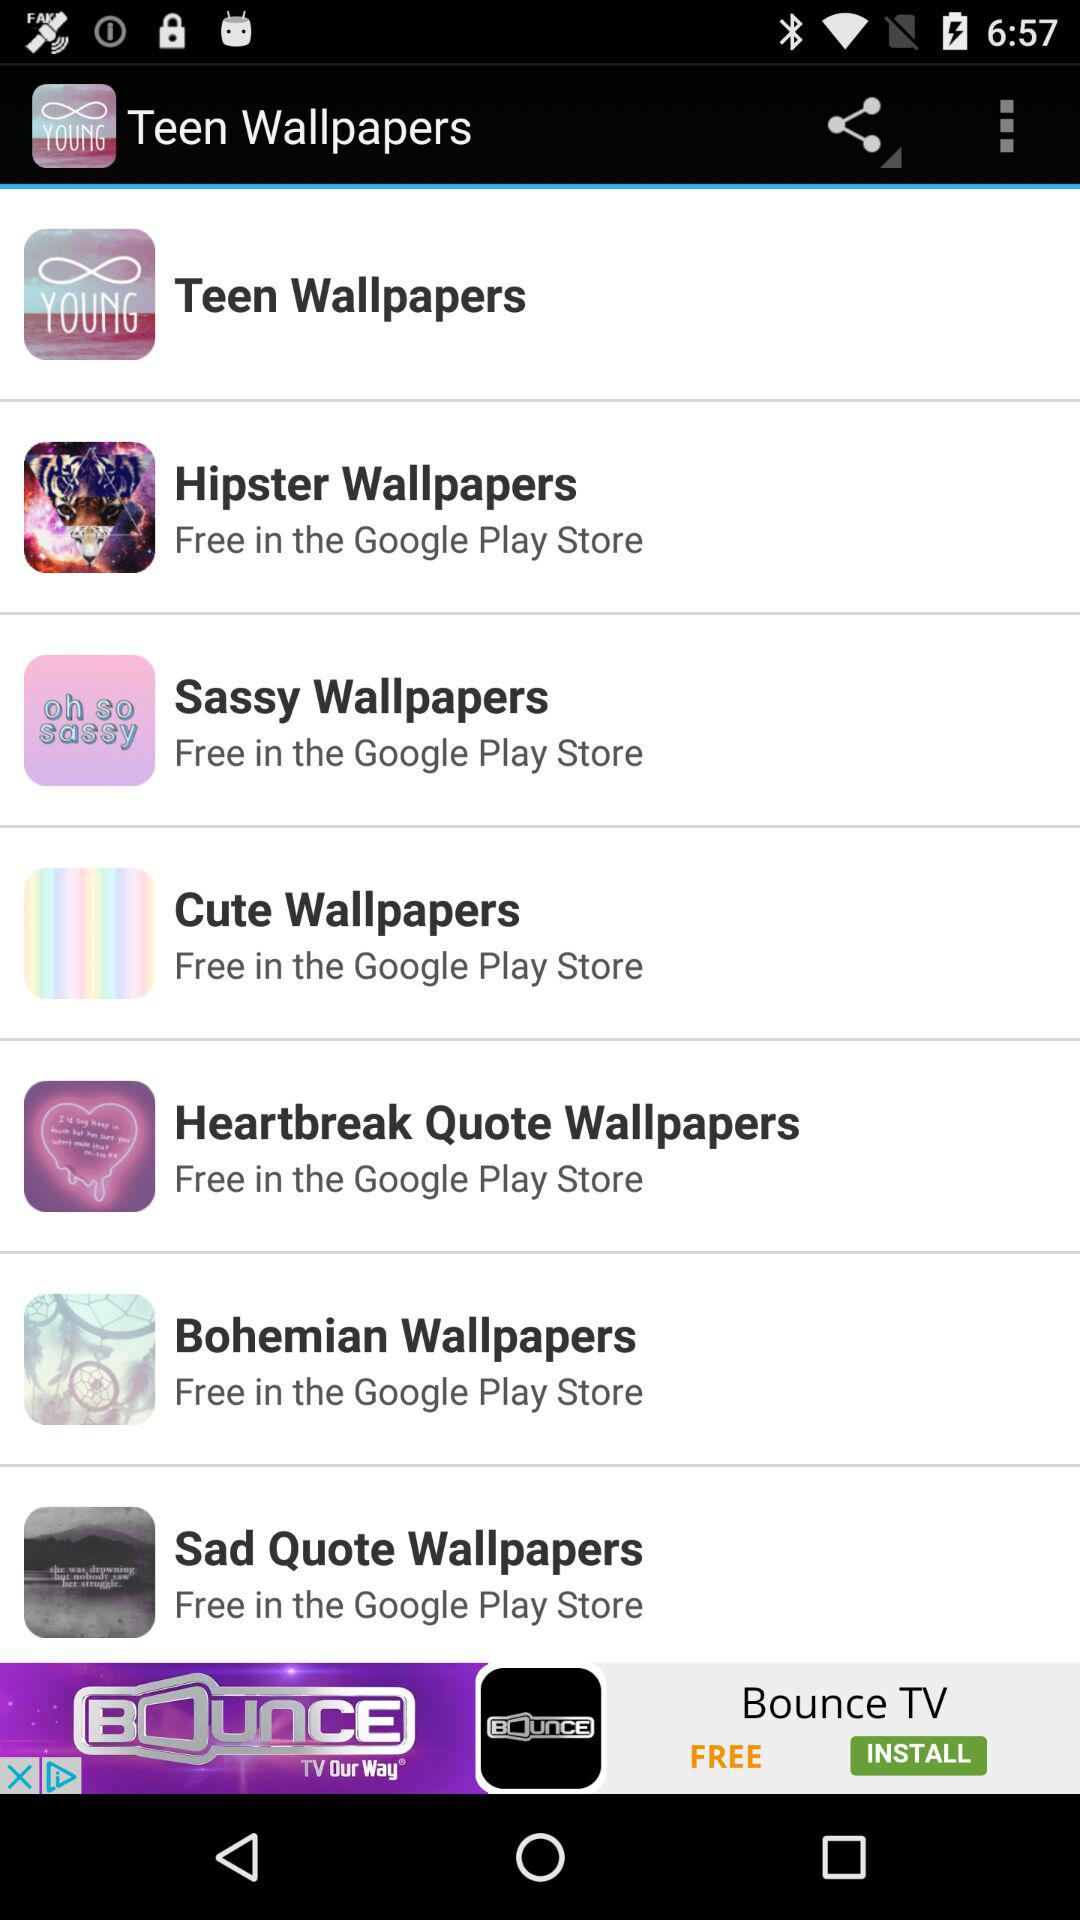Which wallpaper apps are free in the "Google Play Store"? The wallpaper apps that are free in the "Google Play Store" are "Hipster Wallpapers", "Sassy Wallpapers", "Cute Wallpapers", "Heartbreak Quote Wallpapers", "Bohemian Wallpapers" and "Sad Quote Wallpapers". 